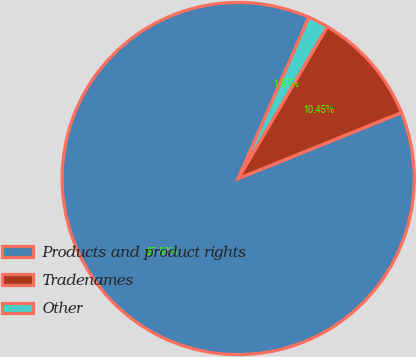Convert chart. <chart><loc_0><loc_0><loc_500><loc_500><pie_chart><fcel>Products and product rights<fcel>Tradenames<fcel>Other<nl><fcel>87.68%<fcel>10.45%<fcel>1.87%<nl></chart> 